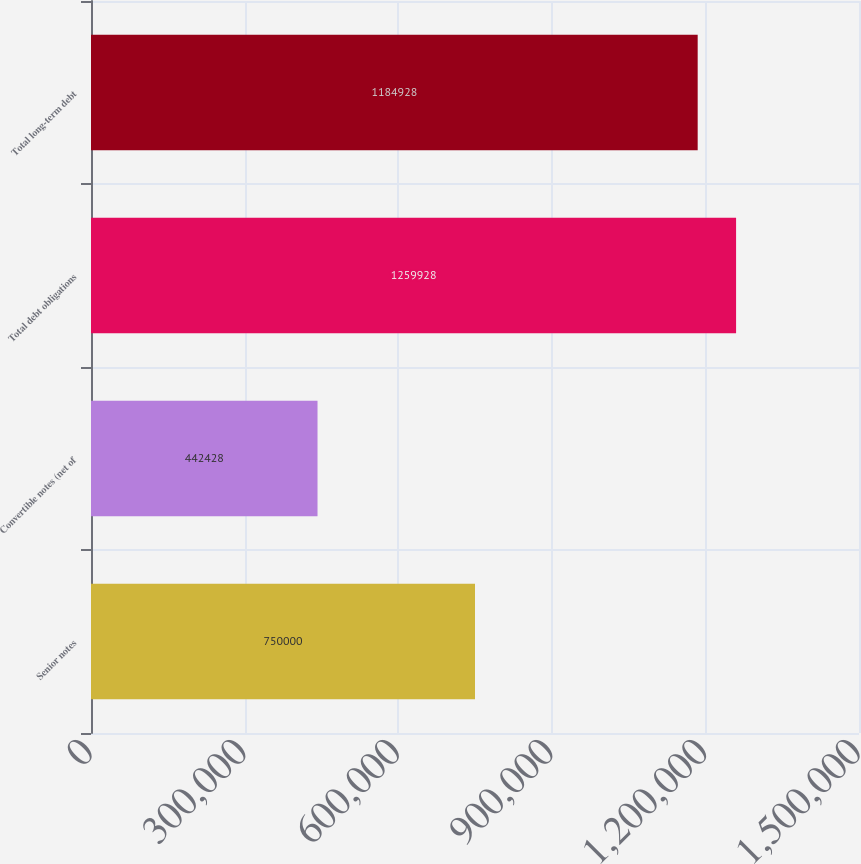Convert chart. <chart><loc_0><loc_0><loc_500><loc_500><bar_chart><fcel>Senior notes<fcel>Convertible notes (net of<fcel>Total debt obligations<fcel>Total long-term debt<nl><fcel>750000<fcel>442428<fcel>1.25993e+06<fcel>1.18493e+06<nl></chart> 